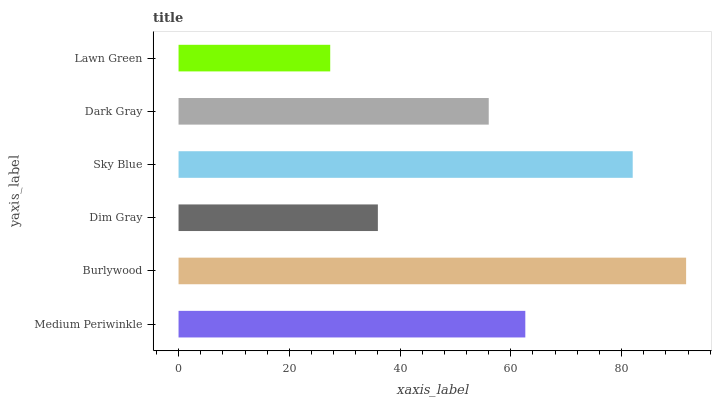Is Lawn Green the minimum?
Answer yes or no. Yes. Is Burlywood the maximum?
Answer yes or no. Yes. Is Dim Gray the minimum?
Answer yes or no. No. Is Dim Gray the maximum?
Answer yes or no. No. Is Burlywood greater than Dim Gray?
Answer yes or no. Yes. Is Dim Gray less than Burlywood?
Answer yes or no. Yes. Is Dim Gray greater than Burlywood?
Answer yes or no. No. Is Burlywood less than Dim Gray?
Answer yes or no. No. Is Medium Periwinkle the high median?
Answer yes or no. Yes. Is Dark Gray the low median?
Answer yes or no. Yes. Is Burlywood the high median?
Answer yes or no. No. Is Burlywood the low median?
Answer yes or no. No. 